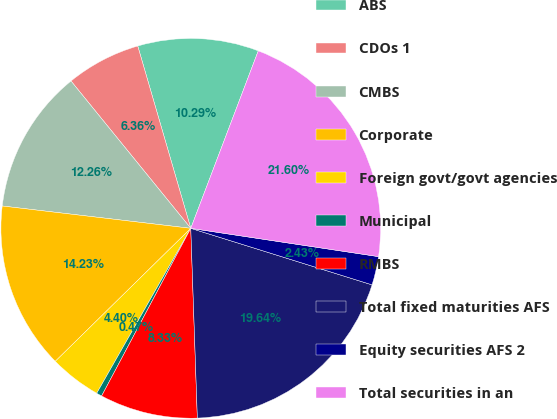Convert chart. <chart><loc_0><loc_0><loc_500><loc_500><pie_chart><fcel>ABS<fcel>CDOs 1<fcel>CMBS<fcel>Corporate<fcel>Foreign govt/govt agencies<fcel>Municipal<fcel>RMBS<fcel>Total fixed maturities AFS<fcel>Equity securities AFS 2<fcel>Total securities in an<nl><fcel>10.29%<fcel>6.36%<fcel>12.26%<fcel>14.23%<fcel>4.4%<fcel>0.47%<fcel>8.33%<fcel>19.64%<fcel>2.43%<fcel>21.6%<nl></chart> 